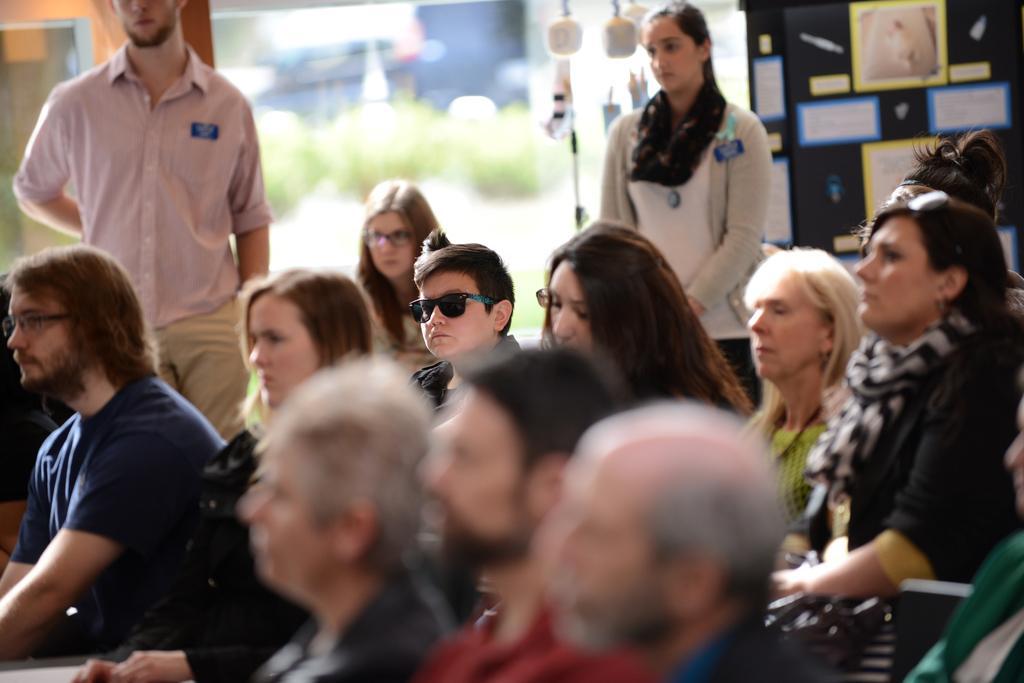Please provide a concise description of this image. In this image, we can see a few people. We can see some boards with text. We can see a pole and some white colored objects. We can see the blurred background. 